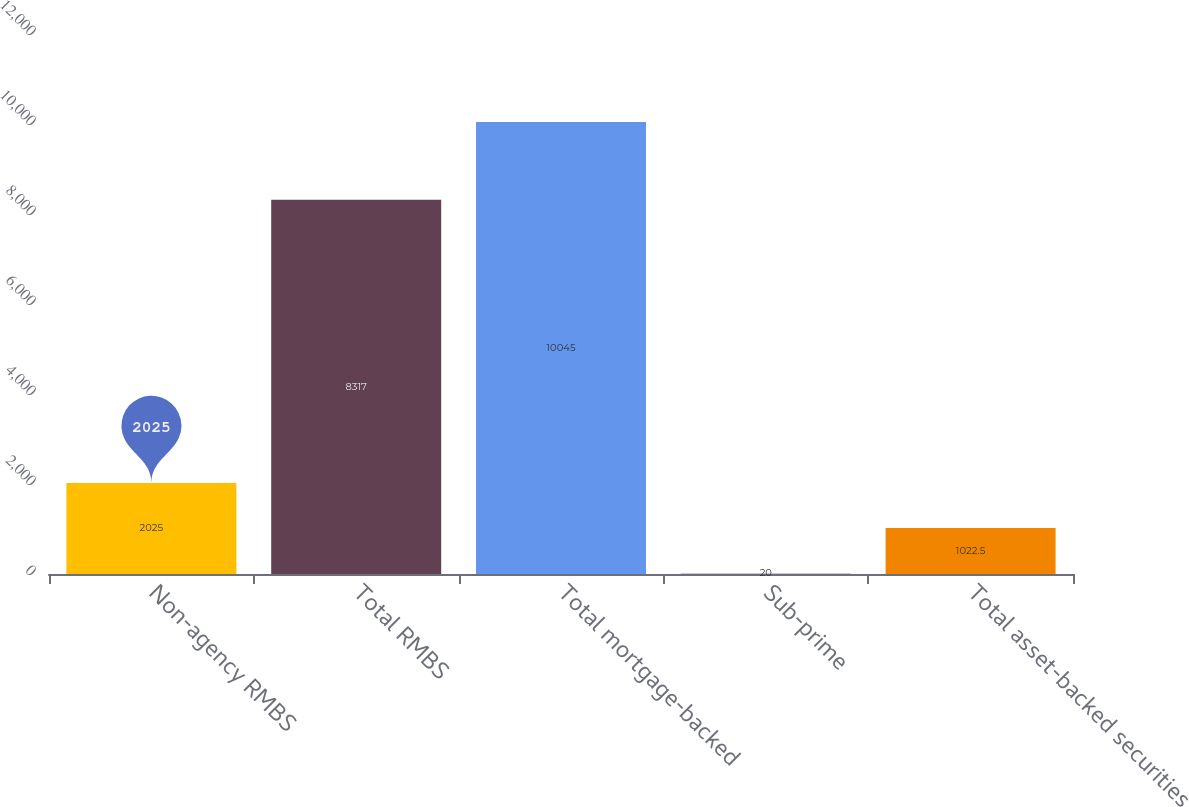Convert chart to OTSL. <chart><loc_0><loc_0><loc_500><loc_500><bar_chart><fcel>Non-agency RMBS<fcel>Total RMBS<fcel>Total mortgage-backed<fcel>Sub-prime<fcel>Total asset-backed securities<nl><fcel>2025<fcel>8317<fcel>10045<fcel>20<fcel>1022.5<nl></chart> 